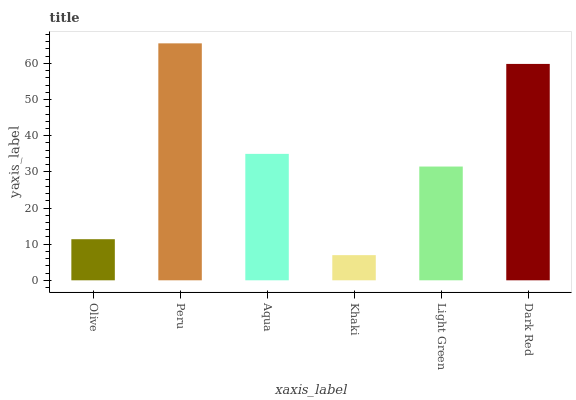Is Khaki the minimum?
Answer yes or no. Yes. Is Peru the maximum?
Answer yes or no. Yes. Is Aqua the minimum?
Answer yes or no. No. Is Aqua the maximum?
Answer yes or no. No. Is Peru greater than Aqua?
Answer yes or no. Yes. Is Aqua less than Peru?
Answer yes or no. Yes. Is Aqua greater than Peru?
Answer yes or no. No. Is Peru less than Aqua?
Answer yes or no. No. Is Aqua the high median?
Answer yes or no. Yes. Is Light Green the low median?
Answer yes or no. Yes. Is Olive the high median?
Answer yes or no. No. Is Khaki the low median?
Answer yes or no. No. 